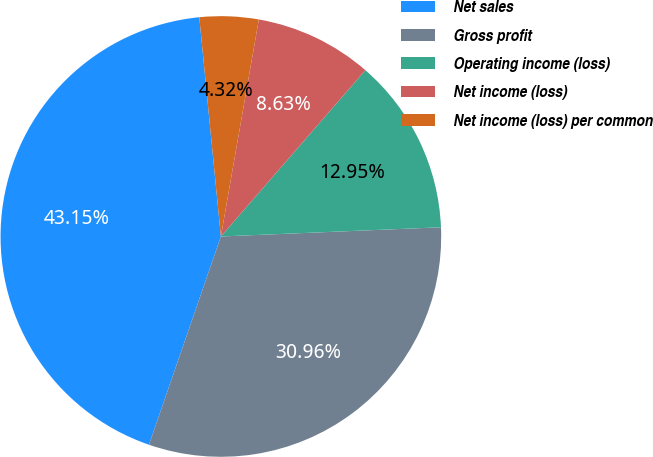<chart> <loc_0><loc_0><loc_500><loc_500><pie_chart><fcel>Net sales<fcel>Gross profit<fcel>Operating income (loss)<fcel>Net income (loss)<fcel>Net income (loss) per common<nl><fcel>43.15%<fcel>30.96%<fcel>12.95%<fcel>8.63%<fcel>4.32%<nl></chart> 